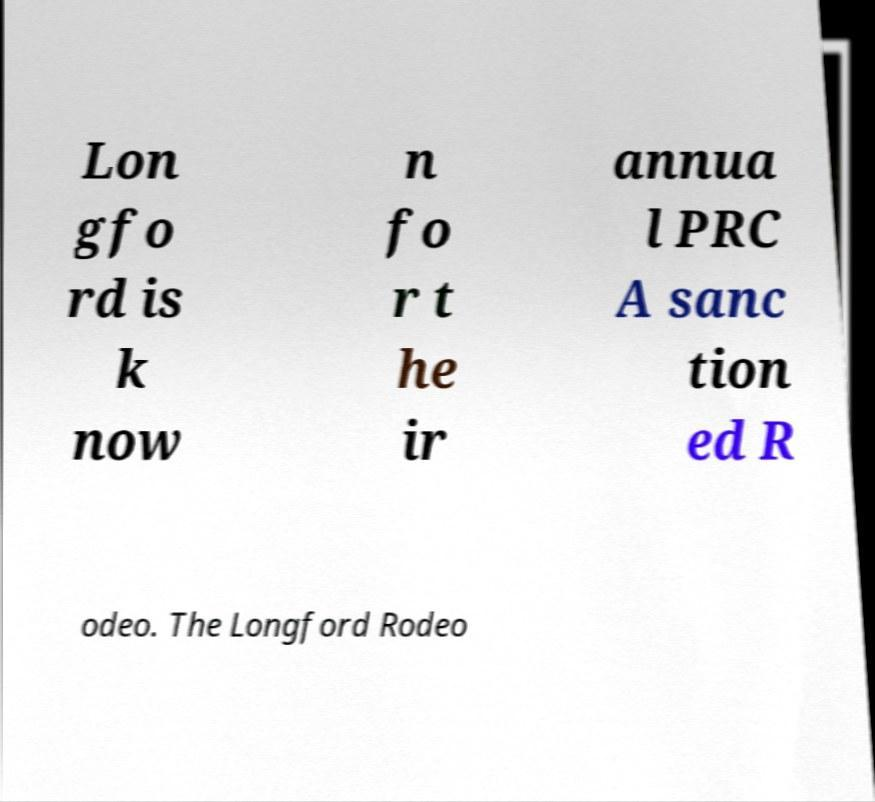Can you accurately transcribe the text from the provided image for me? Lon gfo rd is k now n fo r t he ir annua l PRC A sanc tion ed R odeo. The Longford Rodeo 